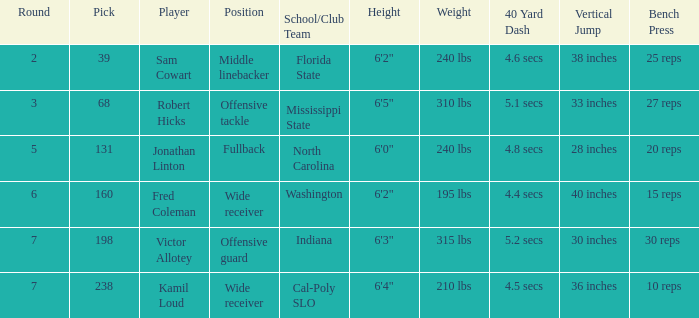Which Player has a Round smaller than 5, and a School/Club Team of florida state? Sam Cowart. 